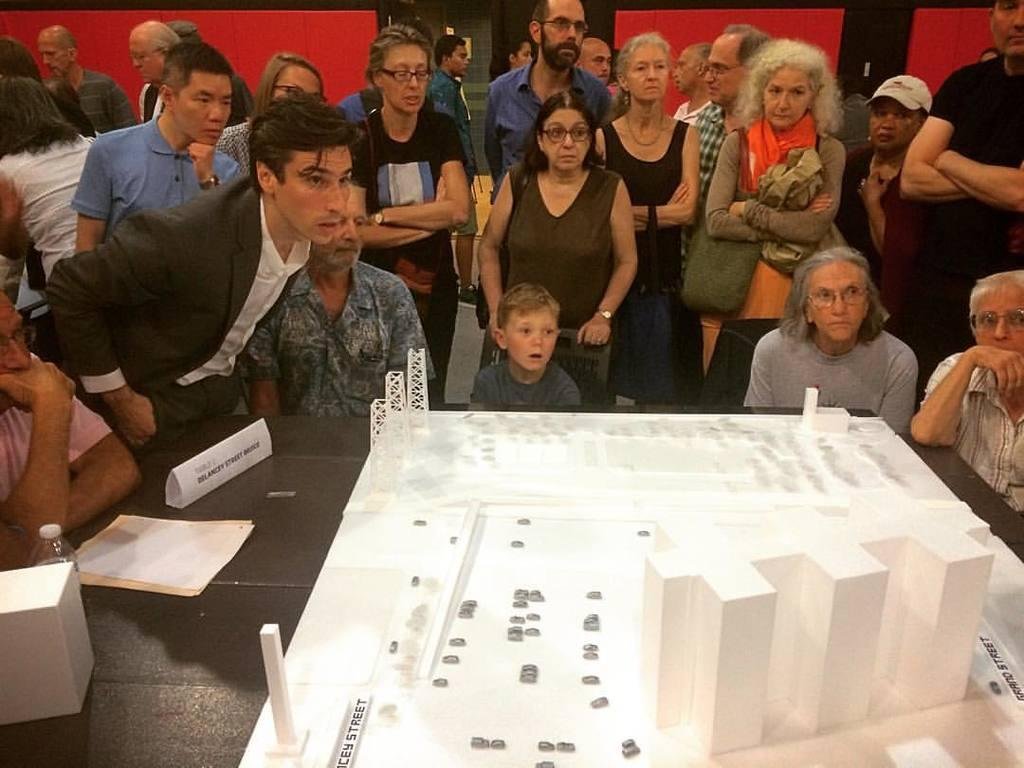What is happening in the image involving people? There are people near a table in the image. What can be seen on the table? There are constructions on the table. What color is the wall in the background? There is a red-colored wall in the background. What architectural feature is visible in the background? There is a door in the background. How many jokes are being told by the people near the table in the image? There is no information about jokes being told in the image. What is the partner's role in the construction process on the table? There is no partner mentioned in the image, and the construction process is not described in detail. 